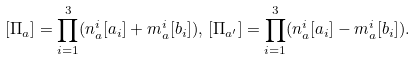Convert formula to latex. <formula><loc_0><loc_0><loc_500><loc_500>[ \Pi _ { a } ] = \prod _ { i = 1 } ^ { 3 } ( n ^ { i } _ { a } [ a _ { i } ] + m ^ { i } _ { a } [ b _ { i } ] ) , \, [ \Pi _ { a ^ { \prime } } ] = \prod _ { i = 1 } ^ { 3 } ( n ^ { i } _ { a } [ a _ { i } ] - m ^ { i } _ { a } [ b _ { i } ] ) . \,</formula> 